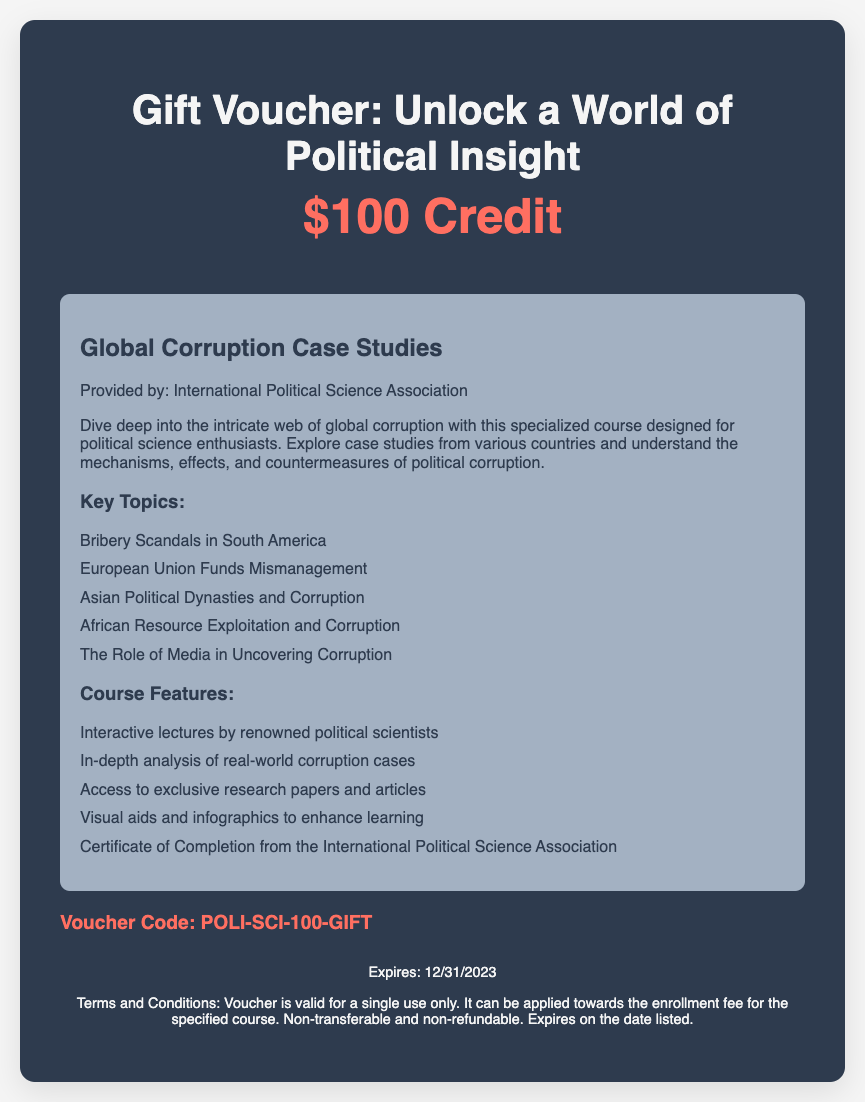what is the value of the gift voucher? The value of the gift voucher is prominently displayed in the header section, indicating how much credit it provides.
Answer: $100 Credit who provides the course? The document mentions the organization responsible for providing the course, which is relevant for identifying credibility and authority.
Answer: International Political Science Association when does the voucher expire? The expiration date is clearly listed in the footer of the document, which is important for using the voucher within the valid timeframe.
Answer: 12/31/2023 what are one of the key topics covered in the course? The course details section outlines several key topics, giving insight into the course focus and content.
Answer: Bribery Scandals in South America what is the voucher code? The unique code for applying the voucher is specified in a separate section, allowing users to know how to redeem their voucher.
Answer: POLI-SCI-100-GIFT how many course features are listed? The document lists several course features, which provides a glimpse into what participants can expect regarding the course experience.
Answer: 5 what type of educational aid is included in the course? The course features highlight different educational resources, aiding in the understanding of corruption case studies.
Answer: Visual aids and infographics what is one of the purposes of the course? The initial description within the course details lays out the goal of the course, focusing on an understanding of a specific political science issue.
Answer: Understand the mechanisms, effects, and countermeasures of political corruption 